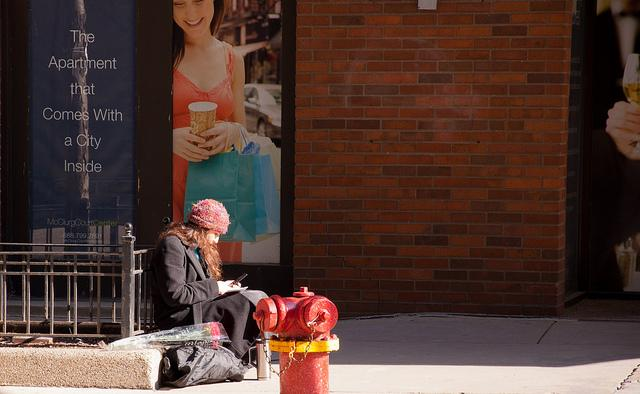What word most closely relates to the red and green things very close to the lady? Please explain your reasoning. romance. Roses are sitting next to a woman who is looking at her phone. people give romantic partners flowers. 